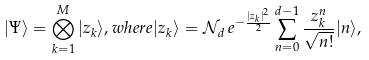<formula> <loc_0><loc_0><loc_500><loc_500>| \Psi \rangle = \bigotimes _ { k = 1 } ^ { M } | z _ { k } \rangle , w h e r e | z _ { k } \rangle = \mathcal { N } _ { d } \, e ^ { - \frac { | z _ { k } | ^ { 2 } } { 2 } } \sum _ { n = 0 } ^ { d - 1 } \frac { z _ { k } ^ { n } } { \sqrt { n ! } } | n \rangle ,</formula> 